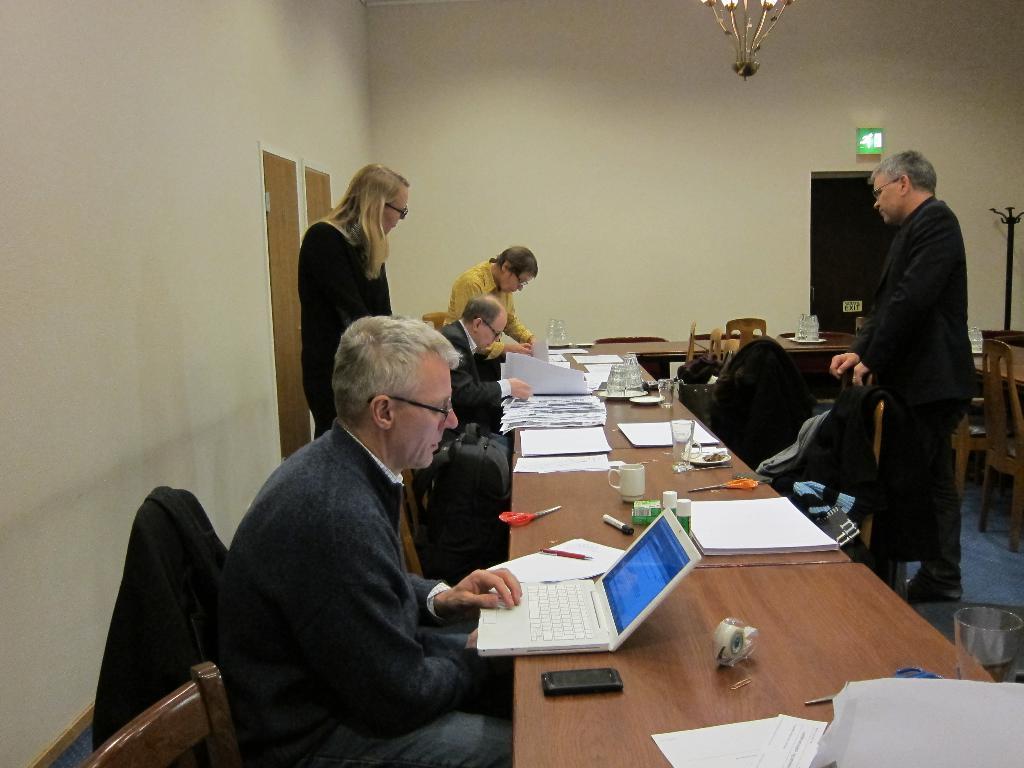Please provide a concise description of this image. In this image i can see a group of people among them, few are sitting on a chair and few are standing on the floor. On the table we have a laptop and few objects on it. 